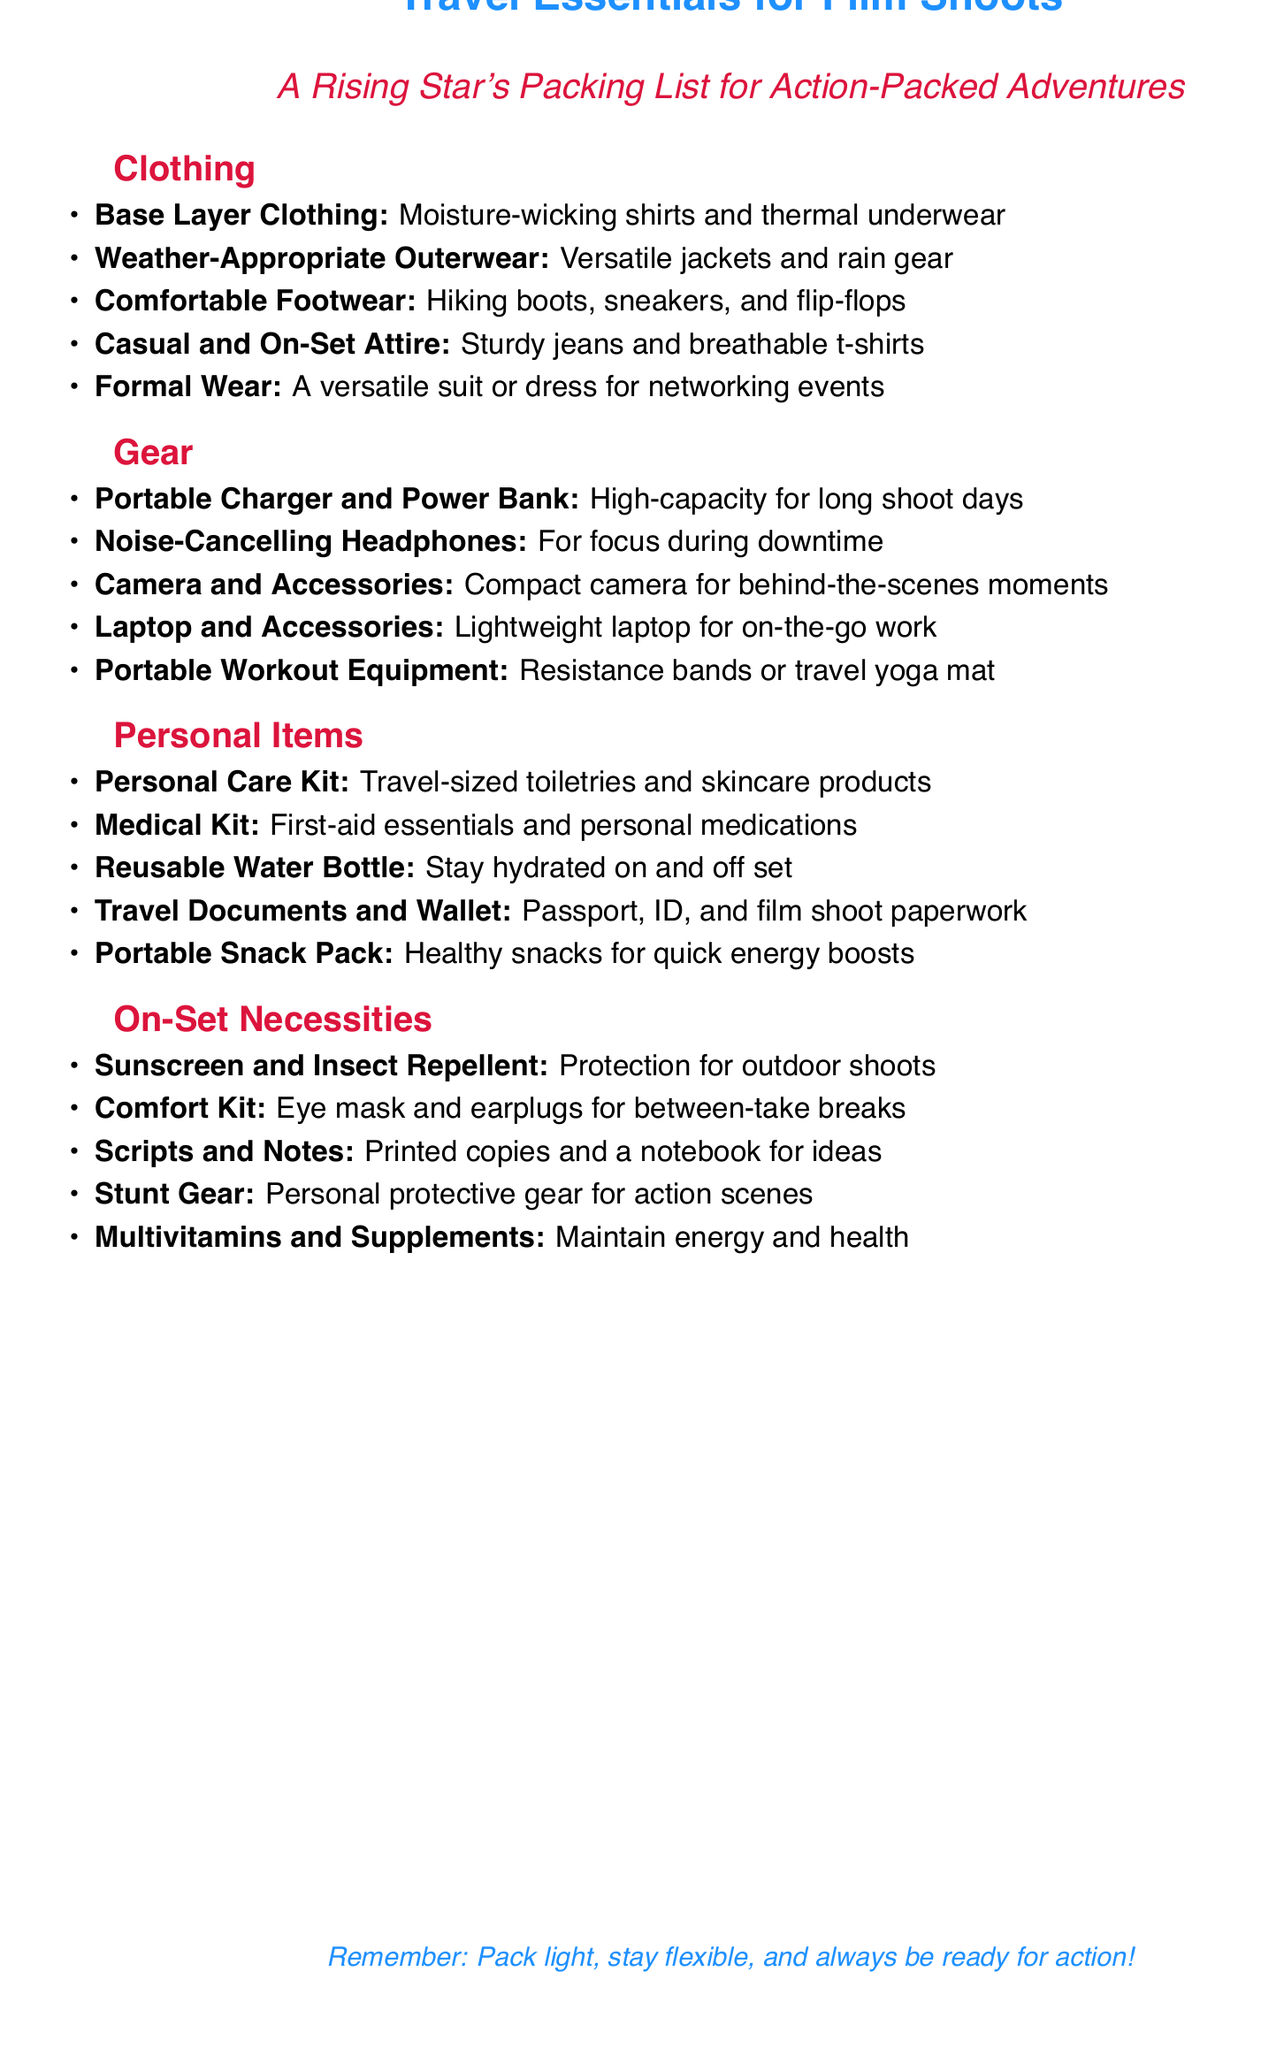What is included in the clothing section? The clothing section lists items such as base layer clothing, outerwear, footwear, casual attire, and formal wear.
Answer: Base Layer Clothing, Weather-Appropriate Outerwear, Comfortable Footwear, Casual and On-Set Attire, Formal Wear How many items are in the gear section? The gear section contains five items listed for packing.
Answer: 5 What should you pack for on-set necessities? On-set necessities include items like sunscreen, comfort kit, scripts, stunt gear, and multivitamins.
Answer: Sunscreen and Insect Repellent, Comfort Kit, Scripts and Notes, Stunt Gear, Multivitamins and Supplements What is a recommended personal care item? The personal items section suggests using travel-sized toiletries as a part of the personal care kit.
Answer: Personal Care Kit What is the color theme of the document? The document features specific colors for titles and section headers, mainly action red and stunt blue.
Answer: Action Red and Stunt Blue Why is a portable charger recommended? A portable charger is essential for keeping devices charged during long shoot days.
Answer: High-capacity for long shoot days What type of footwear is mentioned in the clothing section? The clothing section emphasizes the need for comfortable footwear such as hiking boots and sneakers.
Answer: Hiking boots, sneakers What guidelines are provided for packing? The document offers advice to pack light, stay flexible, and be ready for action.
Answer: Pack light, stay flexible, and always be ready for action What type of snack is encouraged to pack? The personal items section suggests including healthy snacks for quick energy boosts.
Answer: Portable Snack Pack 